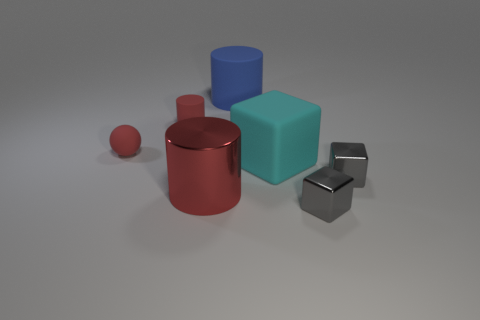Subtract all green balls. How many gray blocks are left? 2 Add 3 tiny red rubber cylinders. How many objects exist? 10 Subtract all cylinders. How many objects are left? 4 Subtract all large matte cylinders. Subtract all red metallic cylinders. How many objects are left? 5 Add 6 big blue cylinders. How many big blue cylinders are left? 7 Add 4 big blue matte things. How many big blue matte things exist? 5 Subtract 1 cyan blocks. How many objects are left? 6 